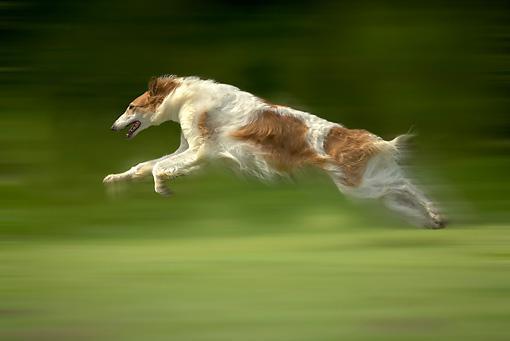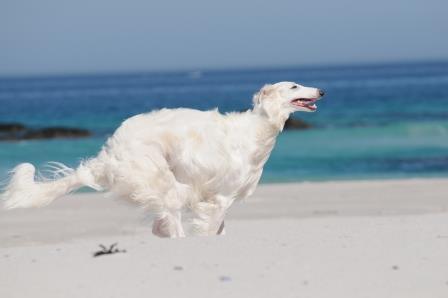The first image is the image on the left, the second image is the image on the right. Assess this claim about the two images: "The right image contains at least one dog that is surrounded by snow.". Correct or not? Answer yes or no. No. The first image is the image on the left, the second image is the image on the right. Examine the images to the left and right. Is the description "Each image features one bounding dog, with one image showing a dog on a beach and the other a dog on a grassy field." accurate? Answer yes or no. Yes. 